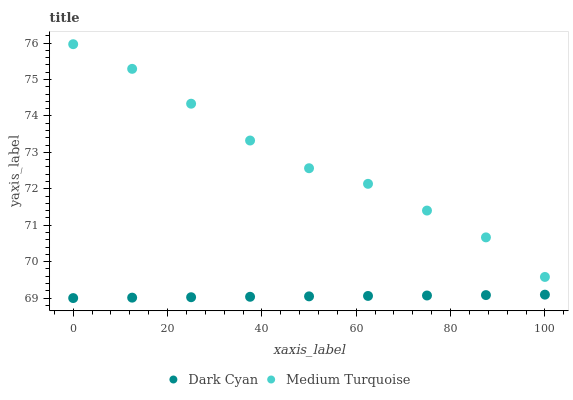Does Dark Cyan have the minimum area under the curve?
Answer yes or no. Yes. Does Medium Turquoise have the maximum area under the curve?
Answer yes or no. Yes. Does Medium Turquoise have the minimum area under the curve?
Answer yes or no. No. Is Dark Cyan the smoothest?
Answer yes or no. Yes. Is Medium Turquoise the roughest?
Answer yes or no. Yes. Is Medium Turquoise the smoothest?
Answer yes or no. No. Does Dark Cyan have the lowest value?
Answer yes or no. Yes. Does Medium Turquoise have the lowest value?
Answer yes or no. No. Does Medium Turquoise have the highest value?
Answer yes or no. Yes. Is Dark Cyan less than Medium Turquoise?
Answer yes or no. Yes. Is Medium Turquoise greater than Dark Cyan?
Answer yes or no. Yes. Does Dark Cyan intersect Medium Turquoise?
Answer yes or no. No. 